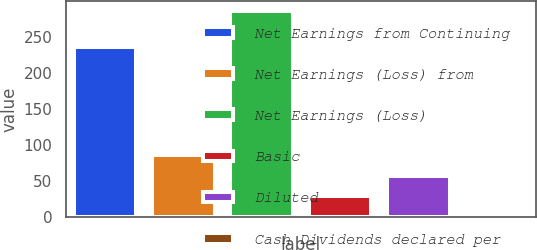Convert chart. <chart><loc_0><loc_0><loc_500><loc_500><bar_chart><fcel>Net Earnings from Continuing<fcel>Net Earnings (Loss) from<fcel>Net Earnings (Loss)<fcel>Basic<fcel>Diluted<fcel>Cash Dividends declared per<nl><fcel>235<fcel>85.9<fcel>285<fcel>29.02<fcel>57.46<fcel>0.58<nl></chart> 